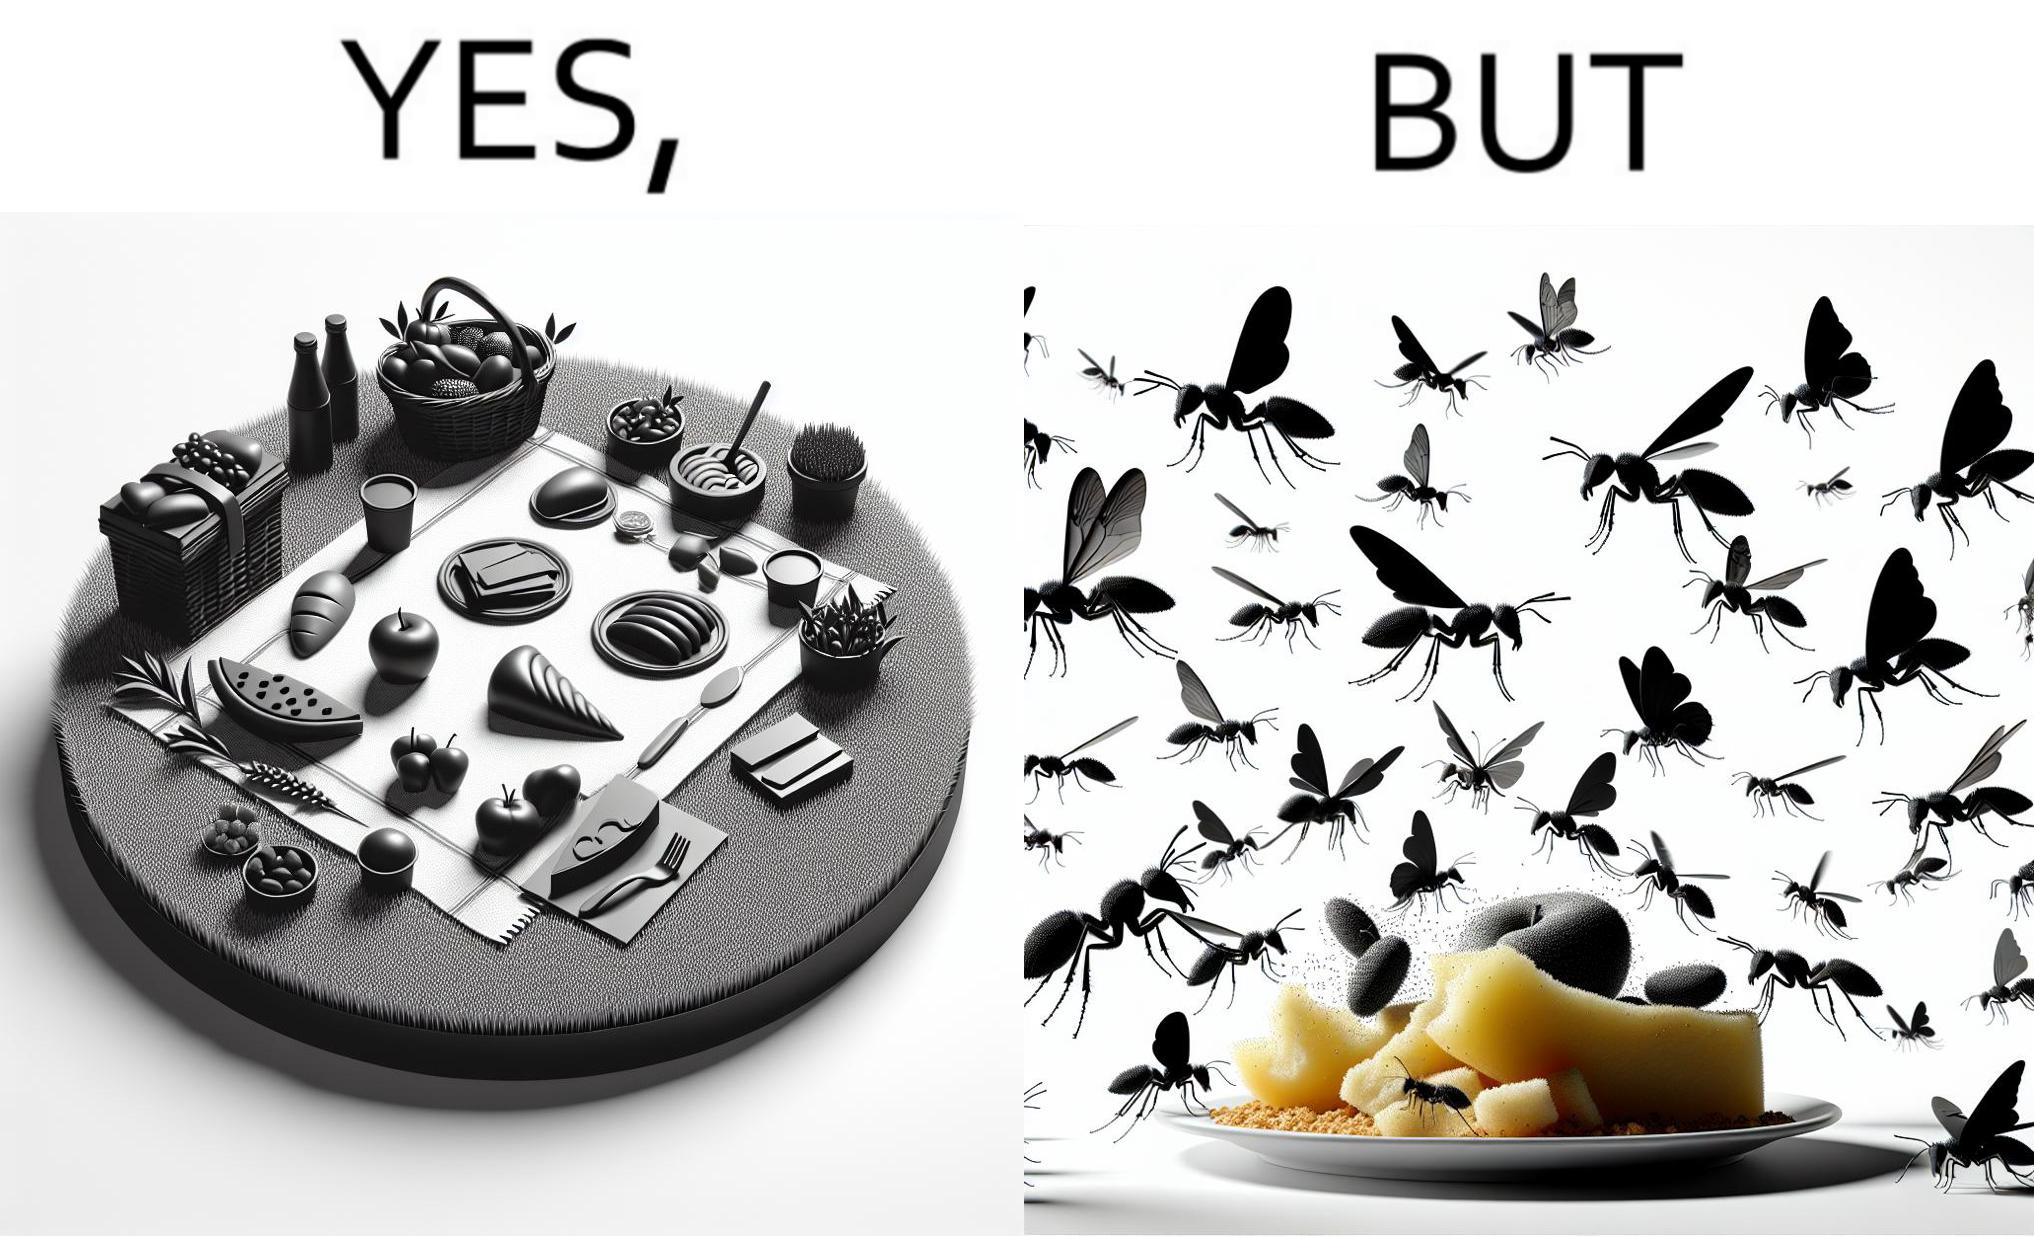What does this image depict? The Picture shows that although we enjoy food in garden but there are some consequences of eating food in garden. Many bugs and bees are attracted towards our food and make our food sometimes non-eatable. 